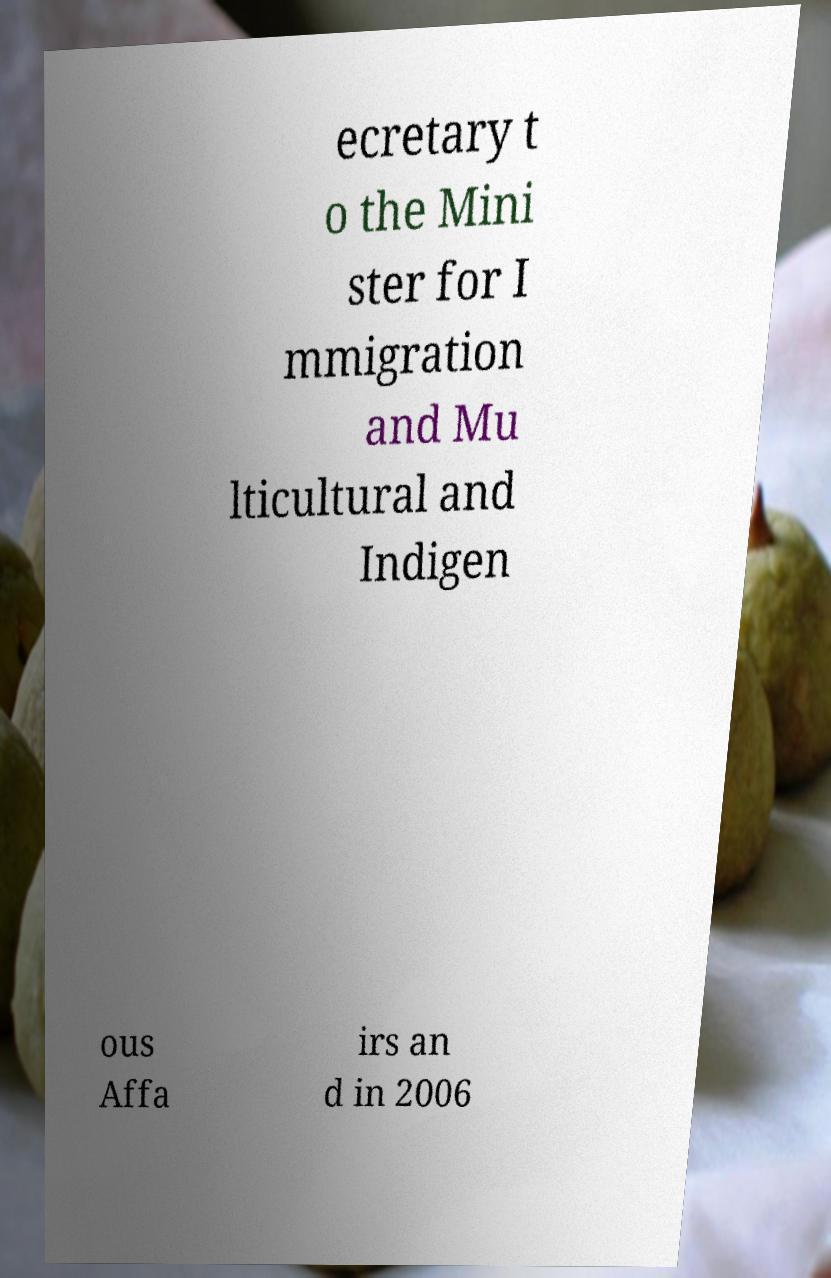Please read and relay the text visible in this image. What does it say? ecretary t o the Mini ster for I mmigration and Mu lticultural and Indigen ous Affa irs an d in 2006 